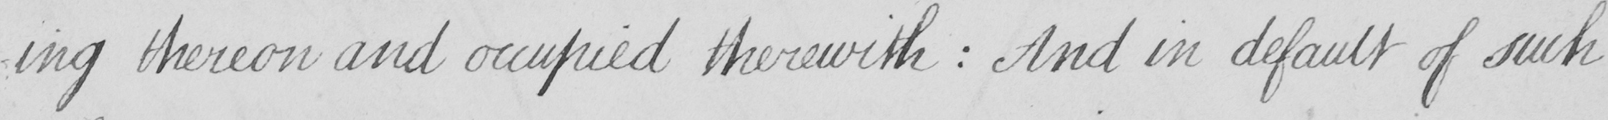Can you tell me what this handwritten text says? -ing thereon and occupied therewith : And in default of such 